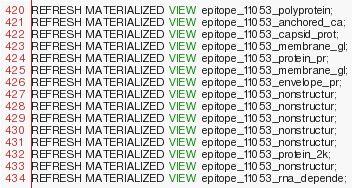Convert code to text. <code><loc_0><loc_0><loc_500><loc_500><_SQL_>REFRESH MATERIALIZED VIEW epitope_11053_polyprotein;
REFRESH MATERIALIZED VIEW epitope_11053_anchored_ca;
REFRESH MATERIALIZED VIEW epitope_11053_capsid_prot;
REFRESH MATERIALIZED VIEW epitope_11053_membrane_gl;
REFRESH MATERIALIZED VIEW epitope_11053_protein_pr;
REFRESH MATERIALIZED VIEW epitope_11053_membrane_gl;
REFRESH MATERIALIZED VIEW epitope_11053_envelope_pr;
REFRESH MATERIALIZED VIEW epitope_11053_nonstructur;
REFRESH MATERIALIZED VIEW epitope_11053_nonstructur;
REFRESH MATERIALIZED VIEW epitope_11053_nonstructur;
REFRESH MATERIALIZED VIEW epitope_11053_nonstructur;
REFRESH MATERIALIZED VIEW epitope_11053_nonstructur;
REFRESH MATERIALIZED VIEW epitope_11053_protein_2k;
REFRESH MATERIALIZED VIEW epitope_11053_nonstructur;
REFRESH MATERIALIZED VIEW epitope_11053_rna_depende;
</code> 